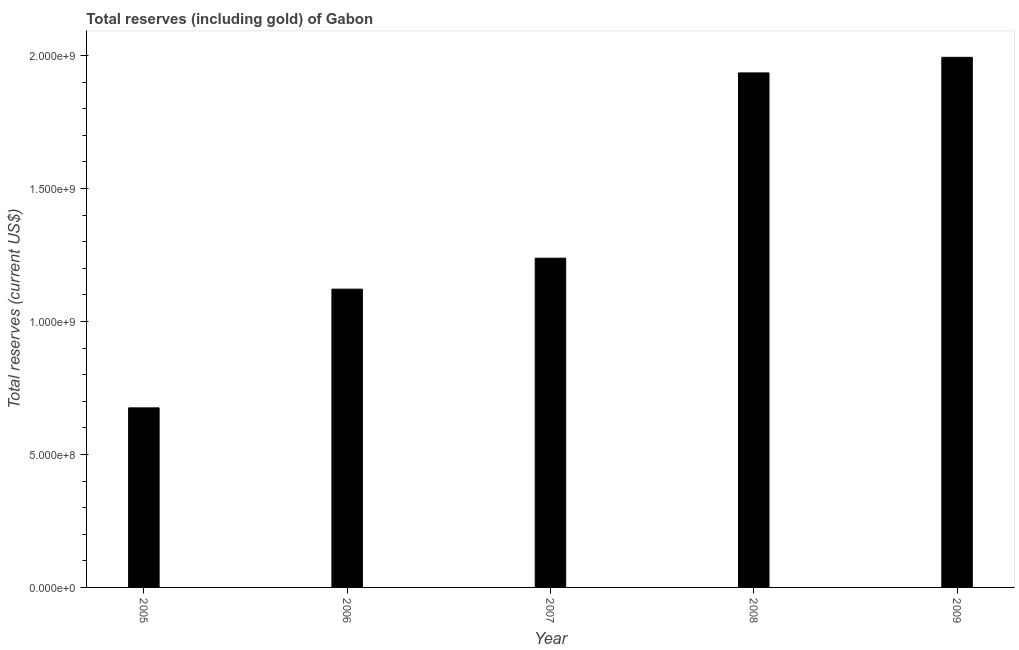Does the graph contain any zero values?
Make the answer very short. No. What is the title of the graph?
Keep it short and to the point. Total reserves (including gold) of Gabon. What is the label or title of the X-axis?
Offer a very short reply. Year. What is the label or title of the Y-axis?
Your response must be concise. Total reserves (current US$). What is the total reserves (including gold) in 2007?
Provide a succinct answer. 1.24e+09. Across all years, what is the maximum total reserves (including gold)?
Offer a terse response. 1.99e+09. Across all years, what is the minimum total reserves (including gold)?
Offer a terse response. 6.75e+08. In which year was the total reserves (including gold) maximum?
Your response must be concise. 2009. What is the sum of the total reserves (including gold)?
Give a very brief answer. 6.96e+09. What is the difference between the total reserves (including gold) in 2006 and 2008?
Offer a very short reply. -8.13e+08. What is the average total reserves (including gold) per year?
Give a very brief answer. 1.39e+09. What is the median total reserves (including gold)?
Provide a succinct answer. 1.24e+09. Do a majority of the years between 2008 and 2007 (inclusive) have total reserves (including gold) greater than 1600000000 US$?
Your answer should be compact. No. What is the ratio of the total reserves (including gold) in 2005 to that in 2008?
Offer a very short reply. 0.35. Is the difference between the total reserves (including gold) in 2005 and 2008 greater than the difference between any two years?
Provide a succinct answer. No. What is the difference between the highest and the second highest total reserves (including gold)?
Keep it short and to the point. 5.86e+07. What is the difference between the highest and the lowest total reserves (including gold)?
Your answer should be compact. 1.32e+09. In how many years, is the total reserves (including gold) greater than the average total reserves (including gold) taken over all years?
Offer a very short reply. 2. How many years are there in the graph?
Your answer should be very brief. 5. What is the difference between two consecutive major ticks on the Y-axis?
Provide a short and direct response. 5.00e+08. Are the values on the major ticks of Y-axis written in scientific E-notation?
Offer a very short reply. Yes. What is the Total reserves (current US$) of 2005?
Make the answer very short. 6.75e+08. What is the Total reserves (current US$) of 2006?
Your answer should be compact. 1.12e+09. What is the Total reserves (current US$) in 2007?
Your answer should be compact. 1.24e+09. What is the Total reserves (current US$) of 2008?
Offer a very short reply. 1.93e+09. What is the Total reserves (current US$) in 2009?
Offer a terse response. 1.99e+09. What is the difference between the Total reserves (current US$) in 2005 and 2006?
Your response must be concise. -4.46e+08. What is the difference between the Total reserves (current US$) in 2005 and 2007?
Your response must be concise. -5.63e+08. What is the difference between the Total reserves (current US$) in 2005 and 2008?
Your answer should be very brief. -1.26e+09. What is the difference between the Total reserves (current US$) in 2005 and 2009?
Give a very brief answer. -1.32e+09. What is the difference between the Total reserves (current US$) in 2006 and 2007?
Your response must be concise. -1.16e+08. What is the difference between the Total reserves (current US$) in 2006 and 2008?
Give a very brief answer. -8.13e+08. What is the difference between the Total reserves (current US$) in 2006 and 2009?
Keep it short and to the point. -8.72e+08. What is the difference between the Total reserves (current US$) in 2007 and 2008?
Your answer should be very brief. -6.97e+08. What is the difference between the Total reserves (current US$) in 2007 and 2009?
Your answer should be compact. -7.55e+08. What is the difference between the Total reserves (current US$) in 2008 and 2009?
Ensure brevity in your answer.  -5.86e+07. What is the ratio of the Total reserves (current US$) in 2005 to that in 2006?
Provide a short and direct response. 0.6. What is the ratio of the Total reserves (current US$) in 2005 to that in 2007?
Your response must be concise. 0.55. What is the ratio of the Total reserves (current US$) in 2005 to that in 2008?
Provide a short and direct response. 0.35. What is the ratio of the Total reserves (current US$) in 2005 to that in 2009?
Offer a very short reply. 0.34. What is the ratio of the Total reserves (current US$) in 2006 to that in 2007?
Keep it short and to the point. 0.91. What is the ratio of the Total reserves (current US$) in 2006 to that in 2008?
Give a very brief answer. 0.58. What is the ratio of the Total reserves (current US$) in 2006 to that in 2009?
Offer a terse response. 0.56. What is the ratio of the Total reserves (current US$) in 2007 to that in 2008?
Offer a terse response. 0.64. What is the ratio of the Total reserves (current US$) in 2007 to that in 2009?
Provide a short and direct response. 0.62. 